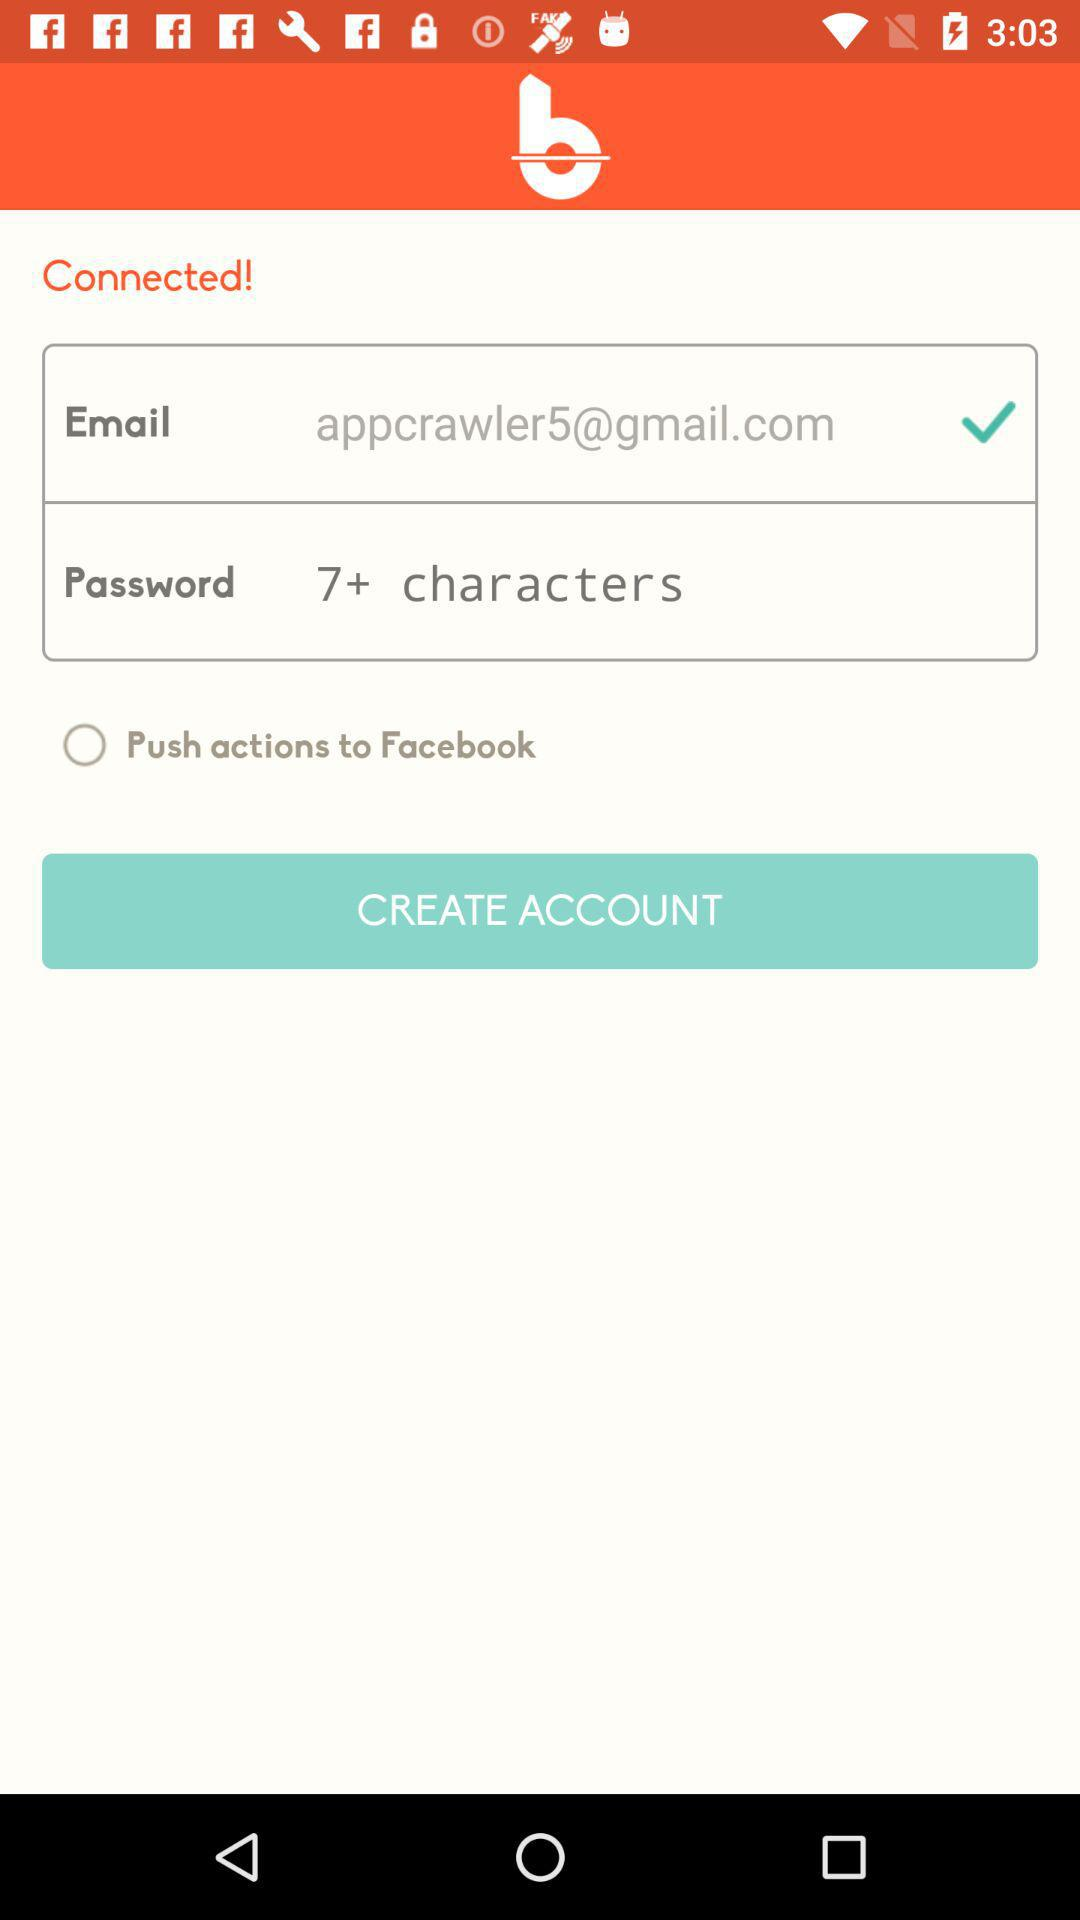How many characters does a password require? A password requires more than 7 characters. 